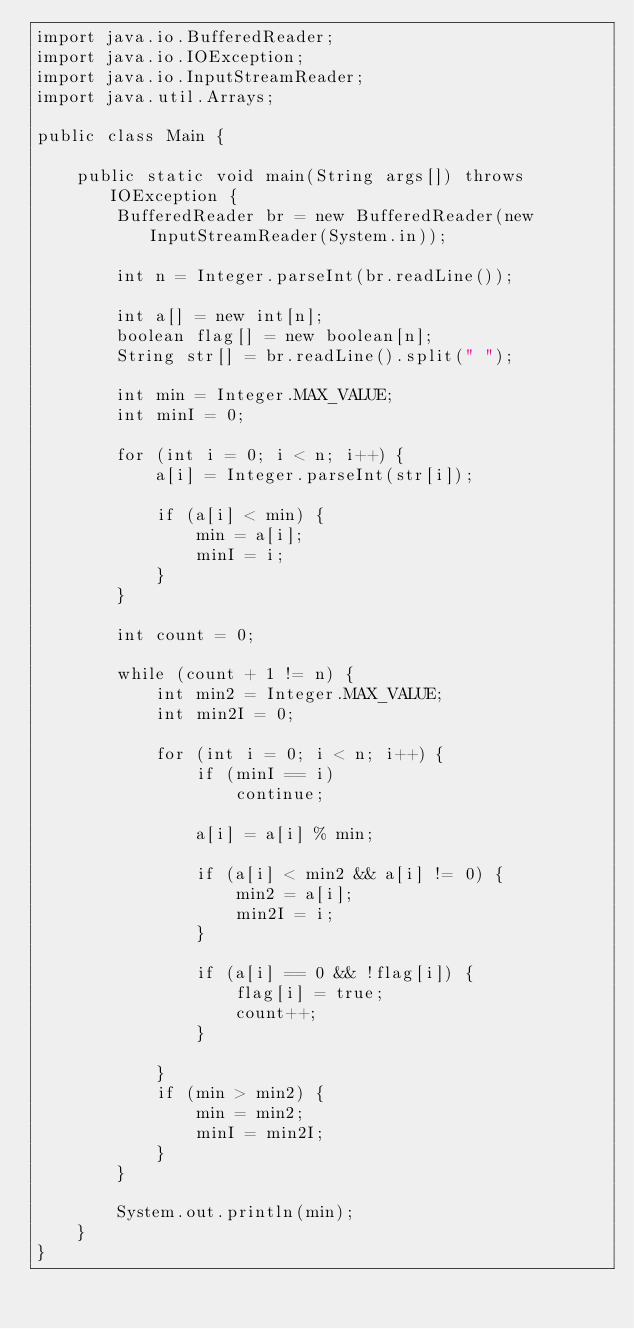<code> <loc_0><loc_0><loc_500><loc_500><_Java_>import java.io.BufferedReader;
import java.io.IOException;
import java.io.InputStreamReader;
import java.util.Arrays;

public class Main {

	public static void main(String args[]) throws IOException {
		BufferedReader br = new BufferedReader(new InputStreamReader(System.in));

		int n = Integer.parseInt(br.readLine());

		int a[] = new int[n];
		boolean flag[] = new boolean[n];
		String str[] = br.readLine().split(" ");

		int min = Integer.MAX_VALUE;
		int minI = 0;

		for (int i = 0; i < n; i++) {
			a[i] = Integer.parseInt(str[i]);

			if (a[i] < min) {
				min = a[i];
				minI = i;
			}
		}

		int count = 0;

		while (count + 1 != n) {
			int min2 = Integer.MAX_VALUE;
			int min2I = 0;

			for (int i = 0; i < n; i++) {
				if (minI == i)
					continue;

				a[i] = a[i] % min;

				if (a[i] < min2 && a[i] != 0) {
					min2 = a[i];
					min2I = i;
				}

				if (a[i] == 0 && !flag[i]) {
					flag[i] = true;
					count++;
				}

			}
			if (min > min2) {
				min = min2;
				minI = min2I;
			}
		}

		System.out.println(min);
	}
}
</code> 